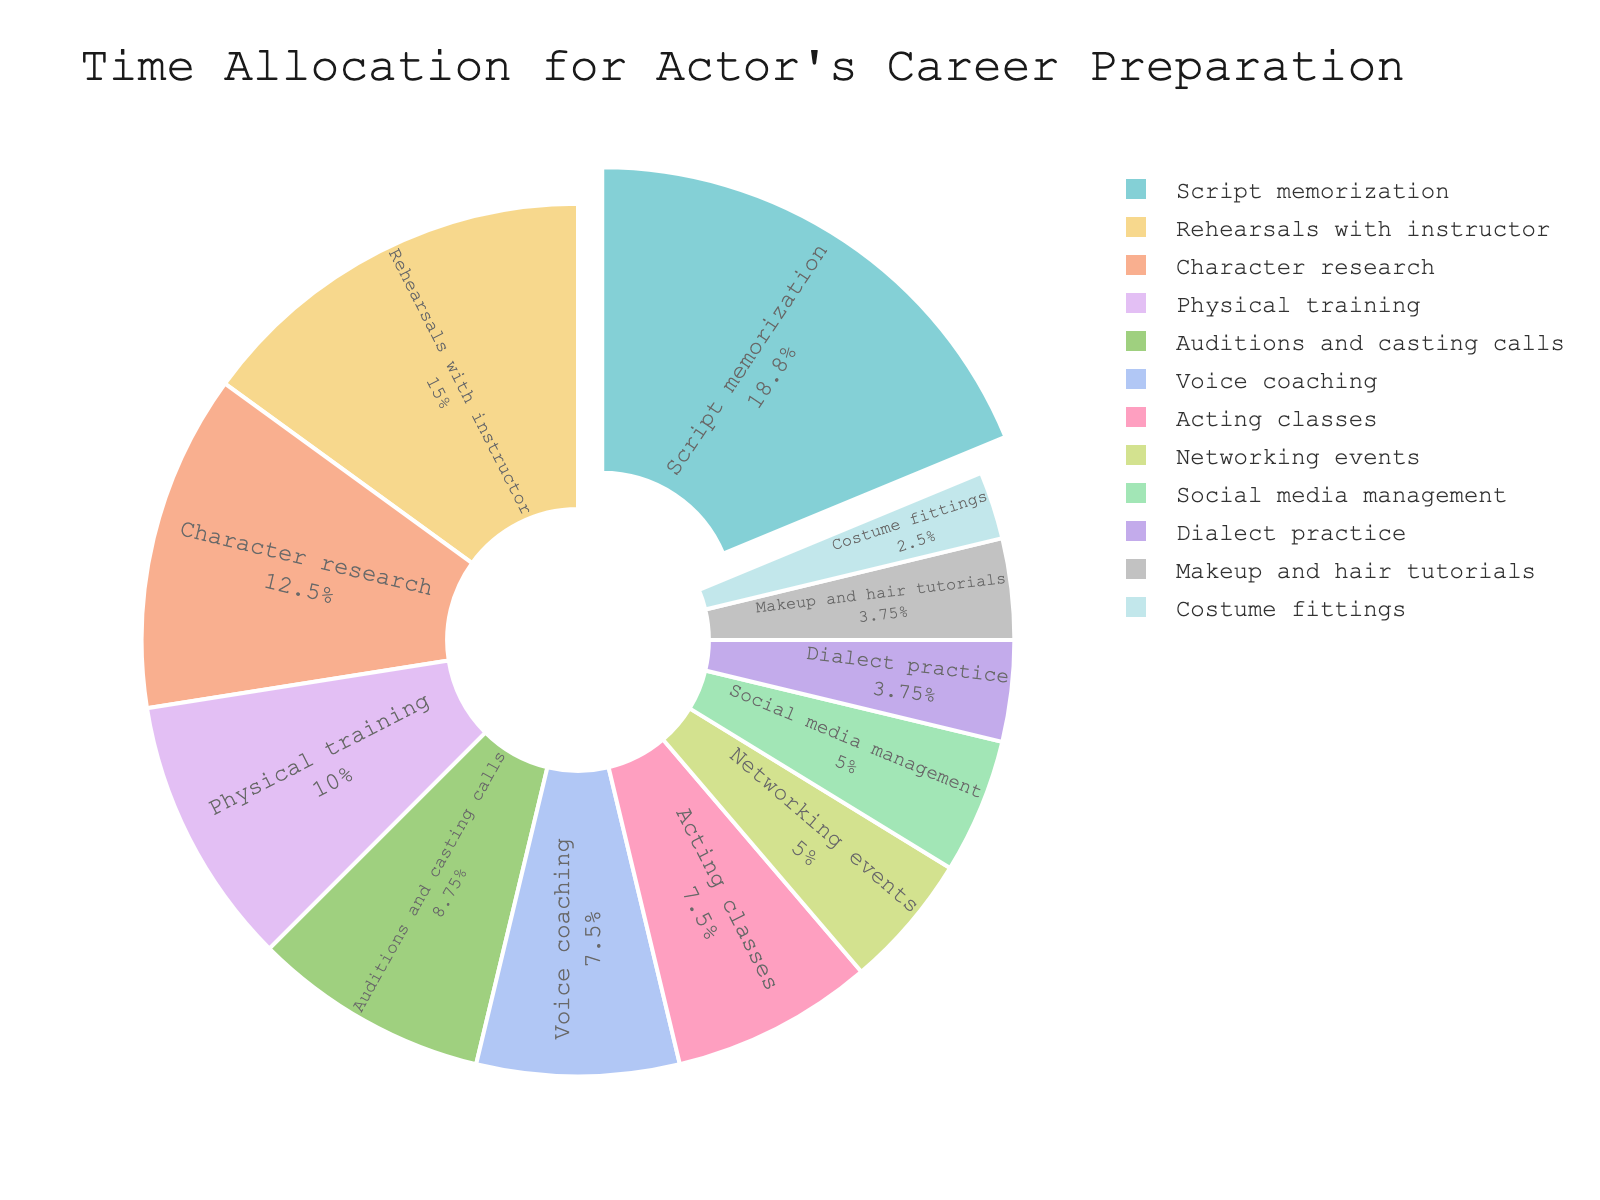Which activity takes up the largest portion of the actor's time? The largest portion can be identified by looking at the slice that is the most visually prominent and is also slightly pulled out from the rest, which is "Script memorization."
Answer: Script memorization How many more hours per week are spent on rehearsals with the instructor compared to auditions and casting calls? Rehearsals with the instructor take 12 hours per week and auditions and casting calls take 7 hours per week. The difference is calculated as 12 - 7 = 5 hours.
Answer: 5 hours What percentage of the actor's time is dedicated to physical training and voice coaching combined? Summing the hours for physical training (8) and voice coaching (6) gives 14 hours. The total hours across all activities sum to 80. The percentage is then calculated as (14/80) * 100 = 17.5%.
Answer: 17.5% Compare the time allocated for acting classes and character research. Which one has more hours, and by how much? Acting classes take 6 hours per week while character research takes 10 hours per week. Character research has more hours by 10 - 6 = 4 hours.
Answer: Character research by 4 hours If the actor spends an equal amount of time on auditions and casting calls, networking events, and social media management, how many hours are spent on these activities in total per week? Summing the hours for auditions and casting calls (7), networking events (4), and social media management (4) equals 7 + 4 + 4 = 15 hours.
Answer: 15 hours What is the average number of hours per week spent on activities related to vocal skills (voice coaching and dialect practice)? The hours for voice coaching are 6 and for dialect practice are 3. Their average is calculated as (6 + 3) / 2 = 4.5 hours.
Answer: 4.5 hours Which takes more time: costume fittings or makeup and hair tutorials? Costume fittings take 2 hours per week while makeup and hair tutorials take 3 hours per week. Makeup and hair tutorials take more time.
Answer: Makeup and hair tutorials What is the ratio of time spent on script memorization to time spent on networking events? Script memorization takes 15 hours per week while networking events take 4 hours per week. The ratio is 15:4.
Answer: 15:4 How many hours per week are spent on activities directly related to physical appearance (physical training, costume fittings, makeup and hair tutorials)? Summing the hours for physical training (8), costume fittings (2), and makeup and hair tutorials (3) equals 8 + 2 + 3 = 13 hours.
Answer: 13 hours What visual attribute distinguishes the activity with the highest time allocation in the pie chart? The activity with the highest time allocation, "Script memorization," is distinguished by its larger slice size and is also slightly pulled out from the rest of the pie.
Answer: Larger slice and pulled out slice 